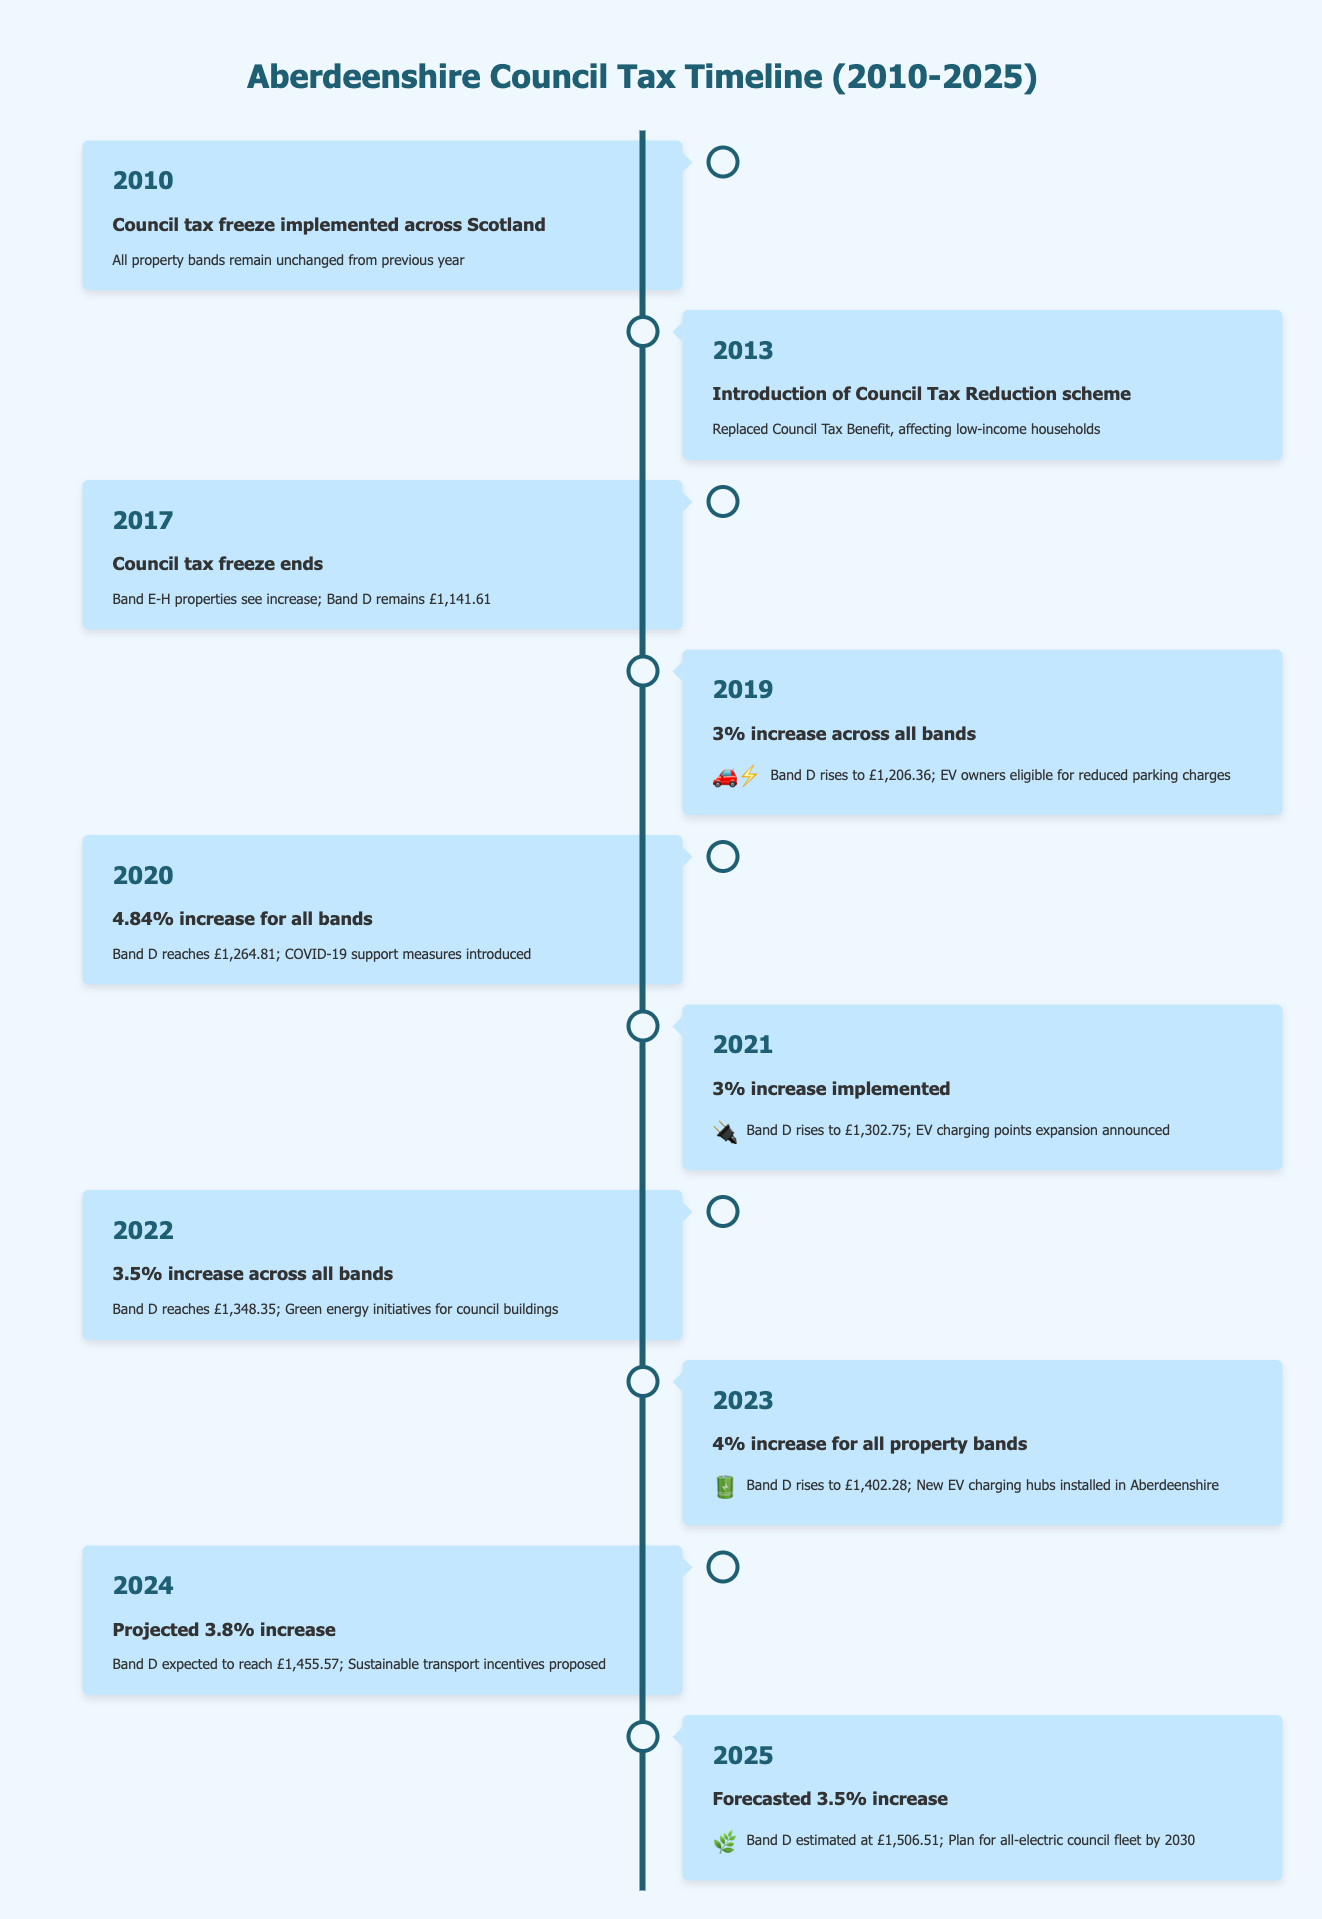What event occurred in 2010 regarding council tax in Aberdeenshire? In 2010, a council tax freeze was implemented across Scotland, which means that all property bands remained unchanged from the previous year.
Answer: Council tax freeze implemented What was the Band D council tax rate in 2019? In 2019, the Band D council tax rate rose to £1,206.36 after a 3% increase across all bands.
Answer: £1,206.36 Was there any increase in the council tax rate in 2020? Yes, there was a 4.84% increase for all bands in 2020, causing the Band D rate to rise significantly.
Answer: Yes What is the percentage increase in Band D from 2020 to 2021? To calculate the percentage increase from 2020 Band D (£1,264.81) to 2021 Band D (£1,302.75), we find the difference of £1,302.75 - £1,264.81 = £37.94. Then, calculate the percentage increase as (37.94 / 1264.81) * 100 = approximately 2.99%.
Answer: Approximately 3% Did the council tax rates for all bands increase in 2023? Yes, in 2023, there was a 4% increase across all property bands, confirming that all bands saw an increase.
Answer: Yes What is the expected council tax rate for Band D in 2024? In 2024, it is projected that Band D will reach £1,455.57, reflecting an increase in the tax rate.
Answer: £1,455.57 If the council tax for Band D in 2025 is estimated at £1,506.51, what was the total increase from 2023? To find the total increase from 2023 (£1,402.28) to 2025 (£1,506.51), calculate the difference: £1,506.51 - £1,402.28 = £104.23. Therefore, the total increase is £104.23 over two years.
Answer: £104.23 Which year saw the introduction of the Council Tax Reduction scheme? The Council Tax Reduction scheme was introduced in 2013, which replaced the Council Tax Benefit affecting low-income households.
Answer: 2013 What was the council tax for Band D in 2022, and how much did it increase from 2021? The Band D council tax in 2022 was £1,348.35. From 2021 (£1,302.75) to 2022, the increase was £1,348.35 - £1,302.75 = £45.60.
Answer: £1,348.35, an increase of £45.60 